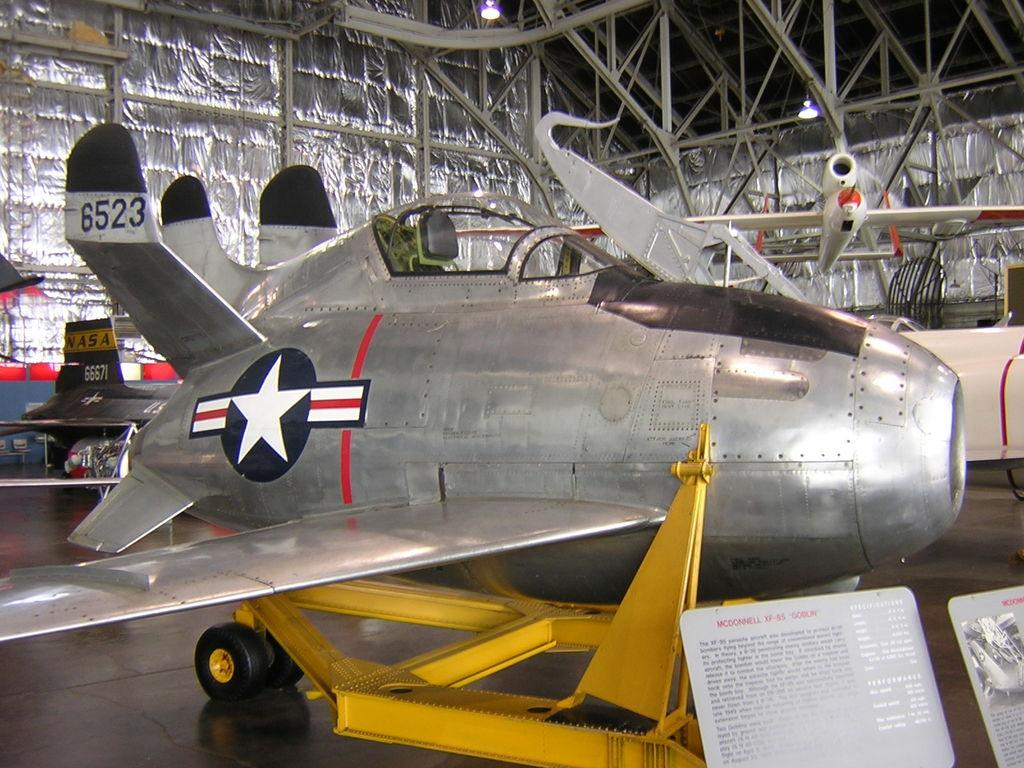What is the main subject of the image? The main subject of the image is an airplane. What type of disgusting sound does the airplane make in the image? There is no sound present in the image, and therefore no such sound can be heard or described. 